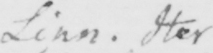What text is written in this handwritten line? Linn . Iter 